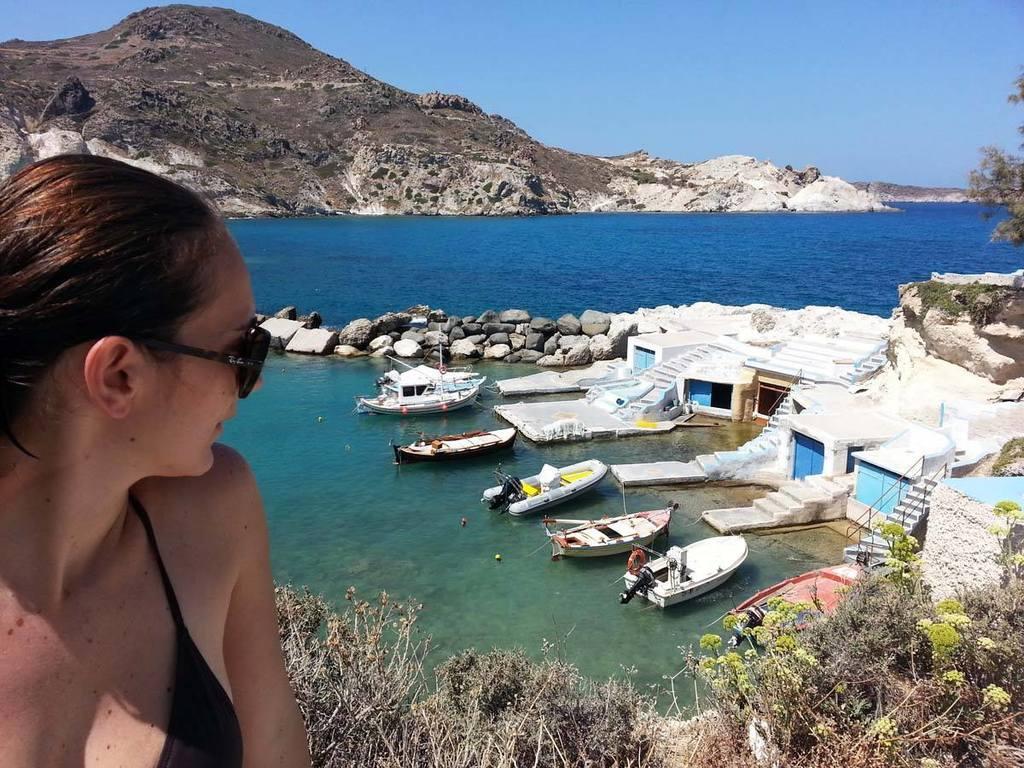Can you describe this image briefly? In this image we can see a woman wearing glasses. We can also see the plants and also a tree. In the background we can see the rocks and also boats on the surface of the sea and stairs and houses. We can also see the hill. Sky is also visible. 